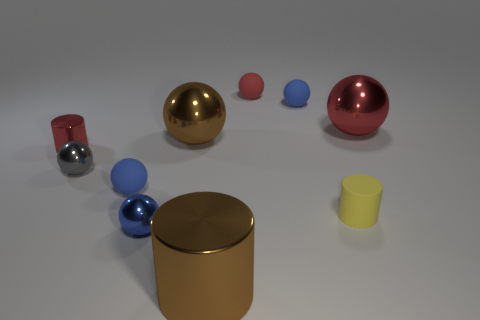Are all the objects in this image solids of revolution? Indeed, each object in this image is a solid of revolution, indicating they were each created by rotating a profile around an axis.  Can you describe the lighting in the scene? The lighting in the scene appears to come from above, casting soft shadows directly underneath the objects, suggesting a diffuse light source, like a softbox or cloudy sky. 